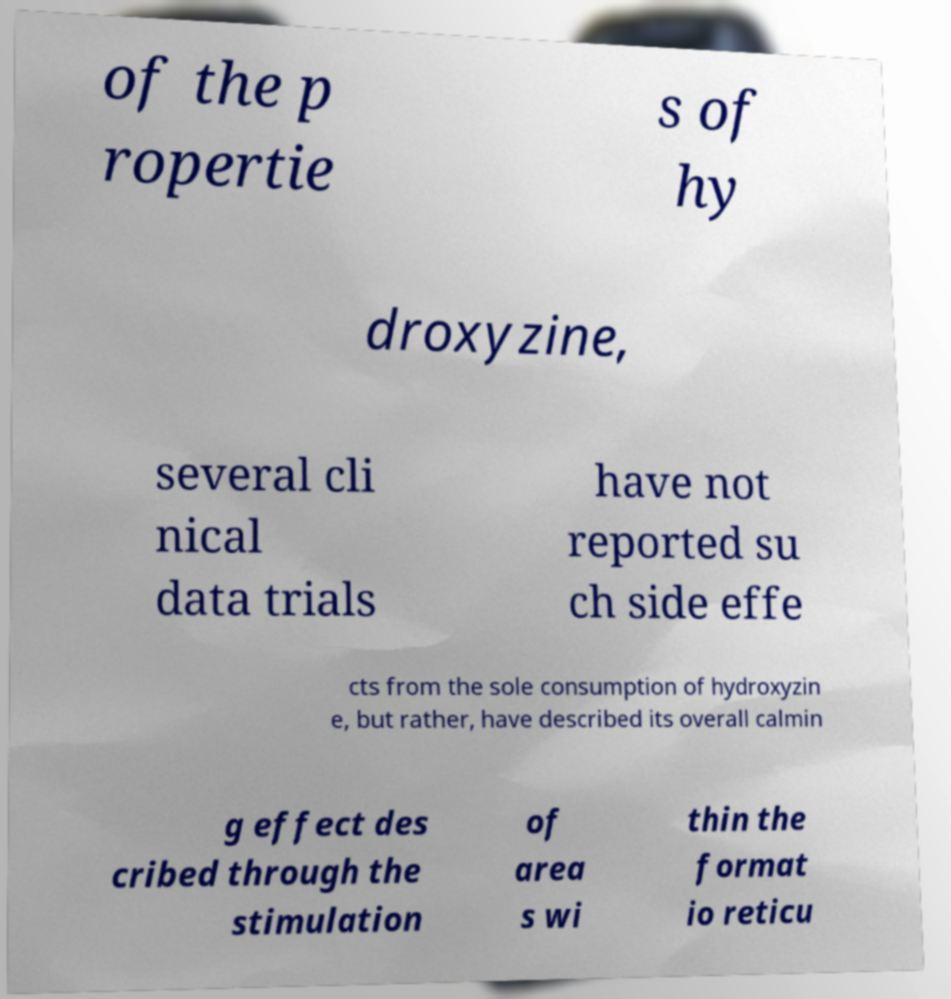Can you read and provide the text displayed in the image?This photo seems to have some interesting text. Can you extract and type it out for me? of the p ropertie s of hy droxyzine, several cli nical data trials have not reported su ch side effe cts from the sole consumption of hydroxyzin e, but rather, have described its overall calmin g effect des cribed through the stimulation of area s wi thin the format io reticu 